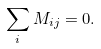<formula> <loc_0><loc_0><loc_500><loc_500>\sum _ { i } M _ { i j } = 0 .</formula> 